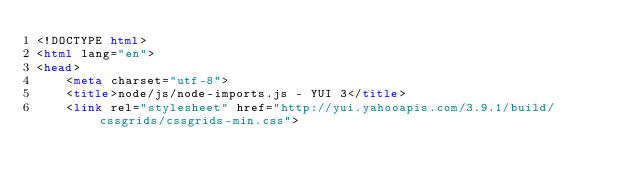Convert code to text. <code><loc_0><loc_0><loc_500><loc_500><_HTML_><!DOCTYPE html>
<html lang="en">
<head>
    <meta charset="utf-8">
    <title>node/js/node-imports.js - YUI 3</title>
    <link rel="stylesheet" href="http://yui.yahooapis.com/3.9.1/build/cssgrids/cssgrids-min.css"></code> 